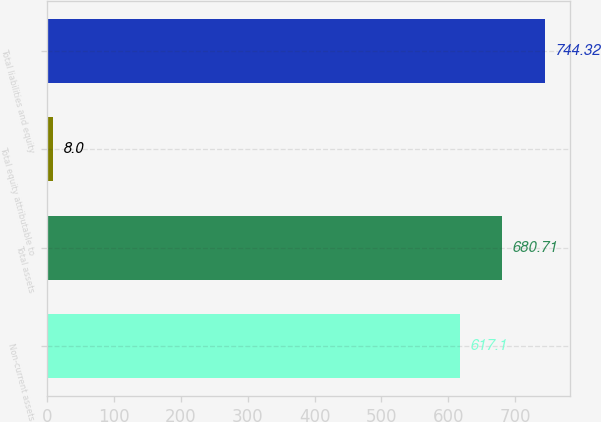Convert chart. <chart><loc_0><loc_0><loc_500><loc_500><bar_chart><fcel>Non-current assets<fcel>Total assets<fcel>Total equity attributable to<fcel>Total liabilities and equity<nl><fcel>617.1<fcel>680.71<fcel>8<fcel>744.32<nl></chart> 